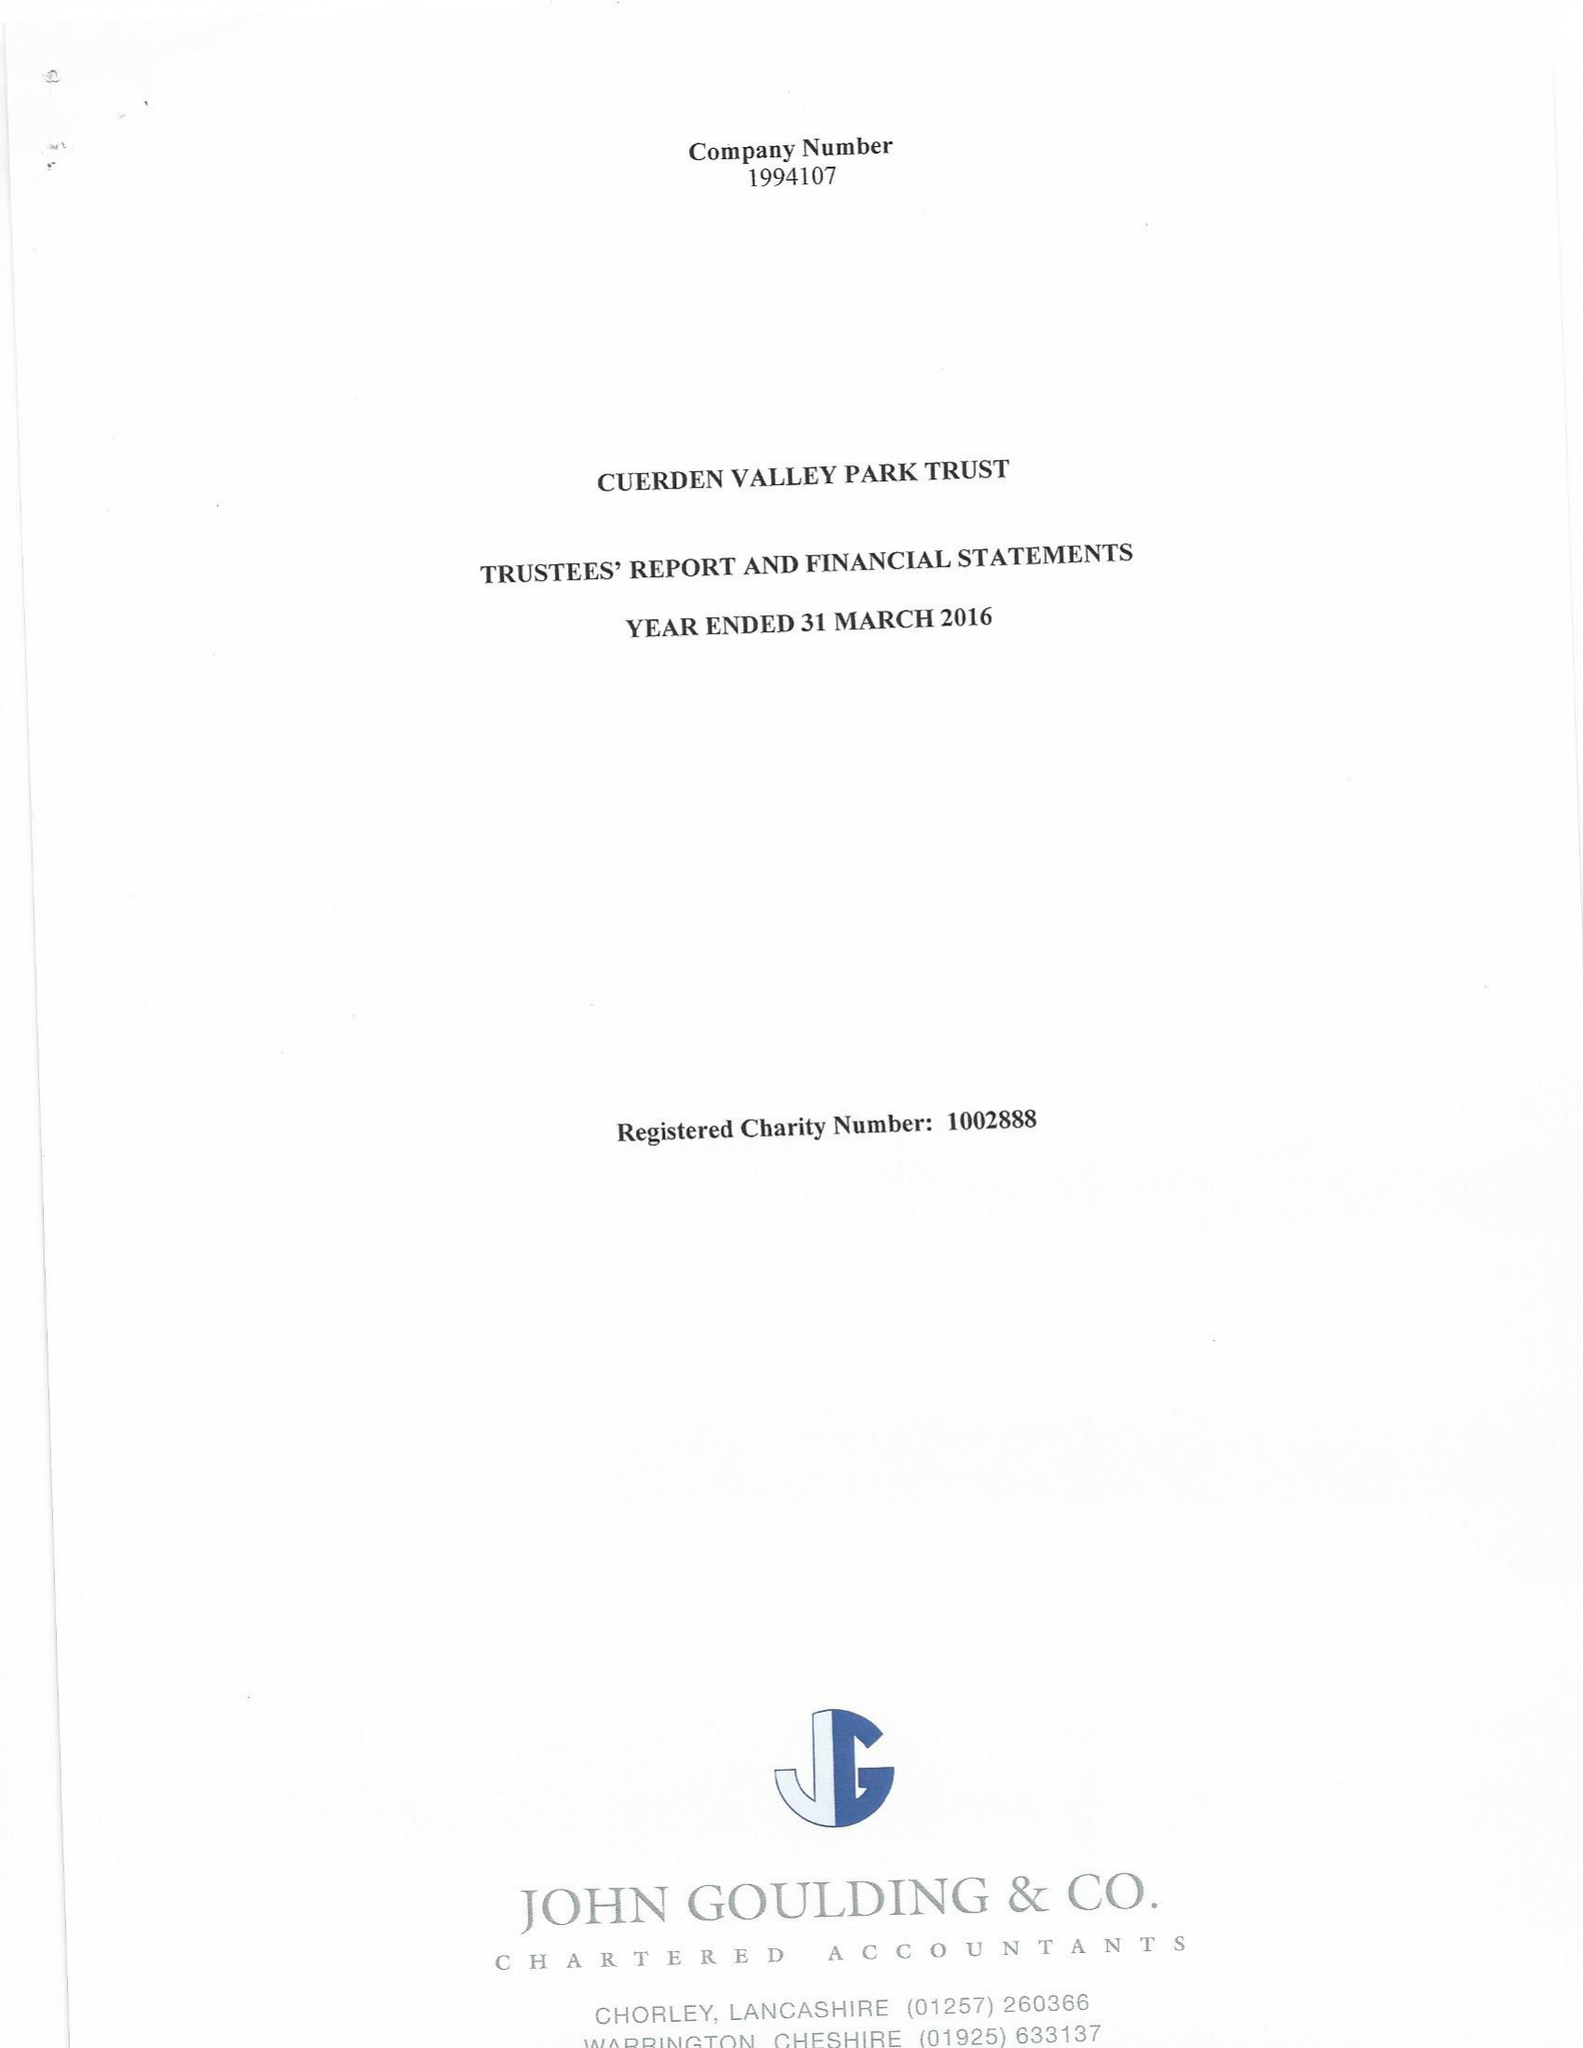What is the value for the income_annually_in_british_pounds?
Answer the question using a single word or phrase. 457840.00 